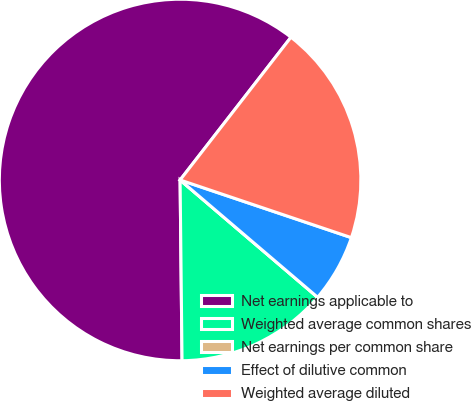Convert chart to OTSL. <chart><loc_0><loc_0><loc_500><loc_500><pie_chart><fcel>Net earnings applicable to<fcel>Weighted average common shares<fcel>Net earnings per common share<fcel>Effect of dilutive common<fcel>Weighted average diluted<nl><fcel>60.68%<fcel>13.59%<fcel>0.0%<fcel>6.07%<fcel>19.66%<nl></chart> 